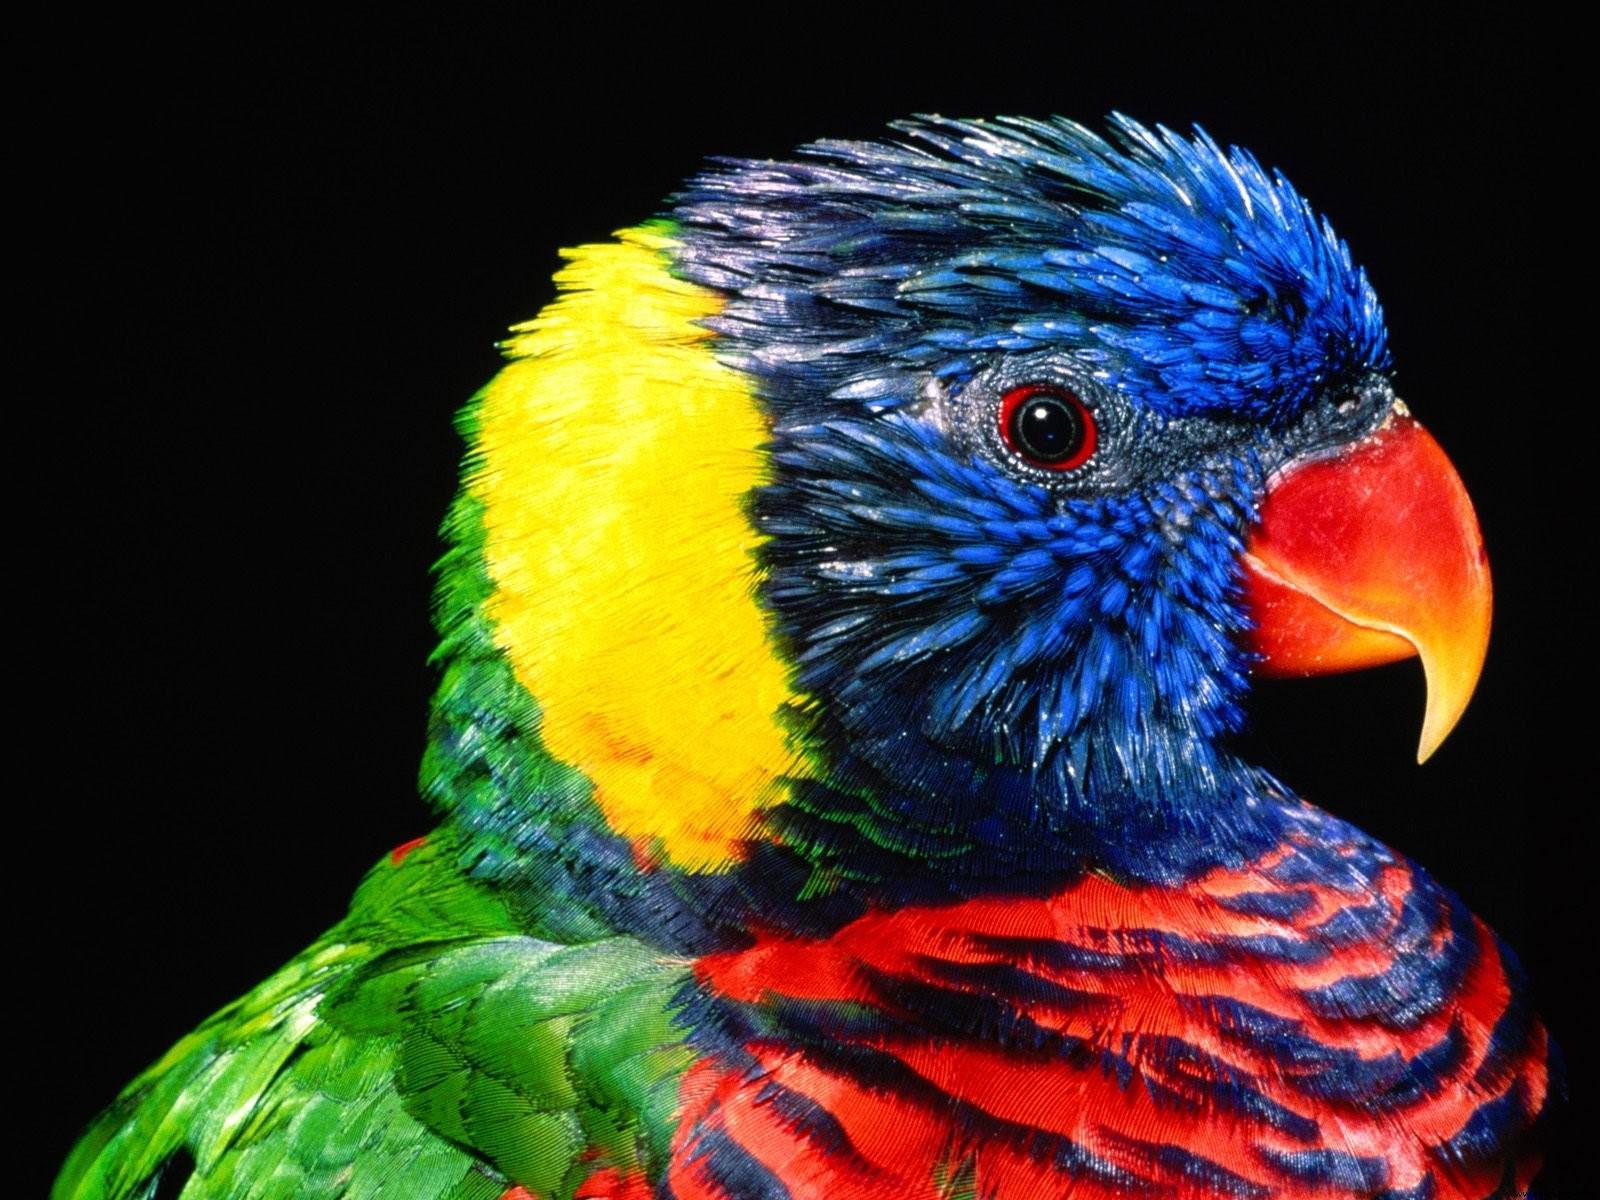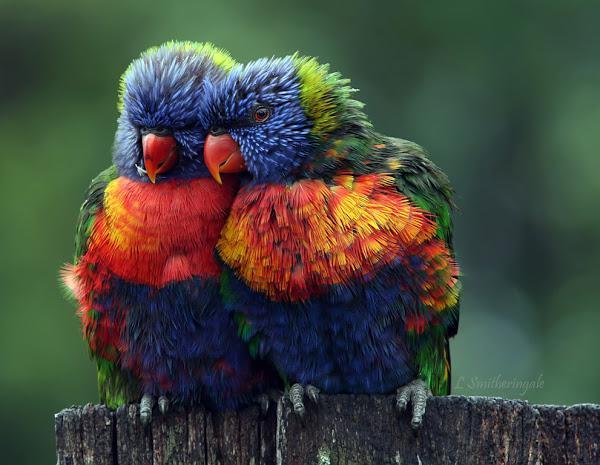The first image is the image on the left, the second image is the image on the right. Evaluate the accuracy of this statement regarding the images: "Some birds are touching each other in at least one photo.". Is it true? Answer yes or no. Yes. The first image is the image on the left, the second image is the image on the right. For the images displayed, is the sentence "The left image contains only one multi-colored parrot." factually correct? Answer yes or no. Yes. 